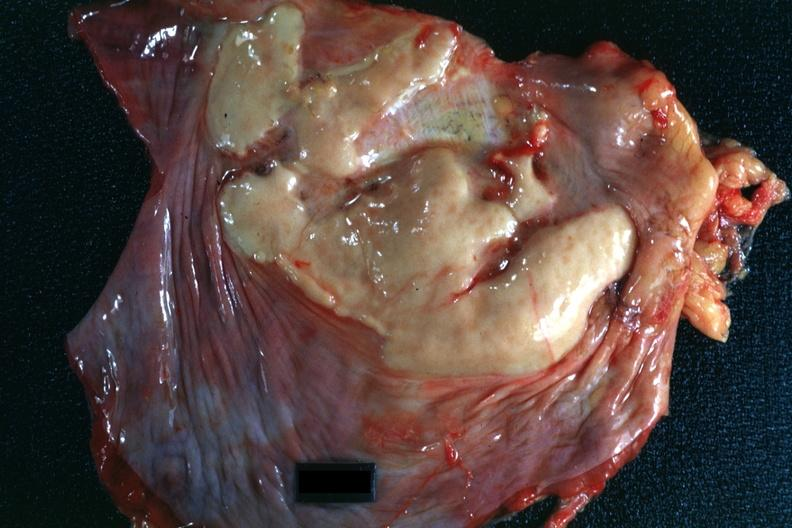what does this image show?
Answer the question using a single word or phrase. Plaque lesion of mesothelioma 